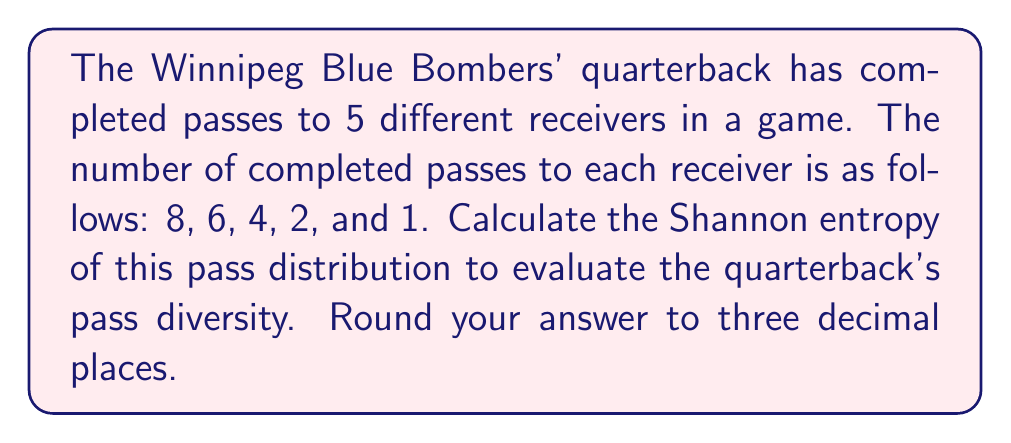Give your solution to this math problem. To calculate the Shannon entropy of the pass distribution, we'll follow these steps:

1) First, we need to calculate the total number of completed passes:
   $8 + 6 + 4 + 2 + 1 = 21$ total passes

2) Next, we calculate the probability of each receiver getting a pass:
   $p_1 = 8/21$, $p_2 = 6/21$, $p_3 = 4/21$, $p_4 = 2/21$, $p_5 = 1/21$

3) The Shannon entropy formula is:
   $$H = -\sum_{i=1}^{n} p_i \log_2(p_i)$$

4) Let's calculate each term:
   $-\frac{8}{21} \log_2(\frac{8}{21}) \approx 0.3912$
   $-\frac{6}{21} \log_2(\frac{6}{21}) \approx 0.3615$
   $-\frac{4}{21} \log_2(\frac{4}{21}) \approx 0.3031$
   $-\frac{2}{21} \log_2(\frac{2}{21}) \approx 0.1984$
   $-\frac{1}{21} \log_2(\frac{1}{21}) \approx 0.1338$

5) Sum all these terms:
   $H = 0.3912 + 0.3615 + 0.3031 + 0.1984 + 0.1338 = 1.3880$

6) Rounding to three decimal places:
   $H \approx 1.388$

This entropy value indicates the level of unpredictability or diversity in the quarterback's pass distribution. A higher value suggests more evenly distributed passes among receivers.
Answer: 1.388 bits 